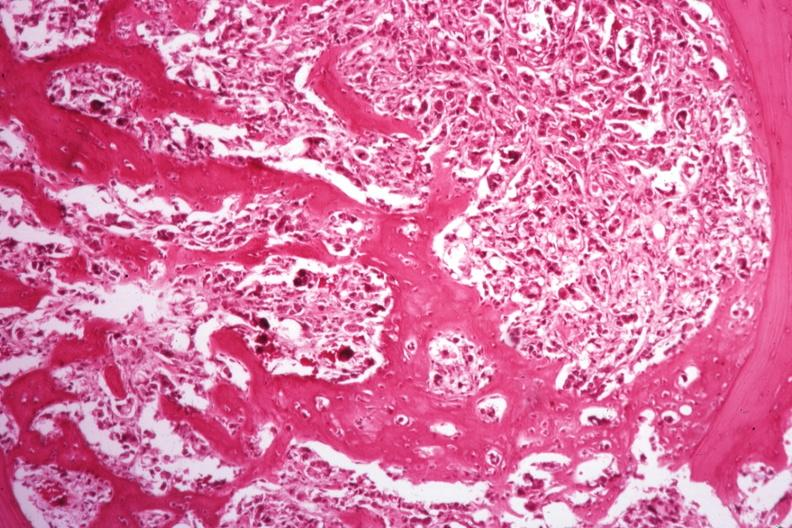how does this image show islands of tumor?
Answer the question using a single word or phrase. With nice new bone formation 